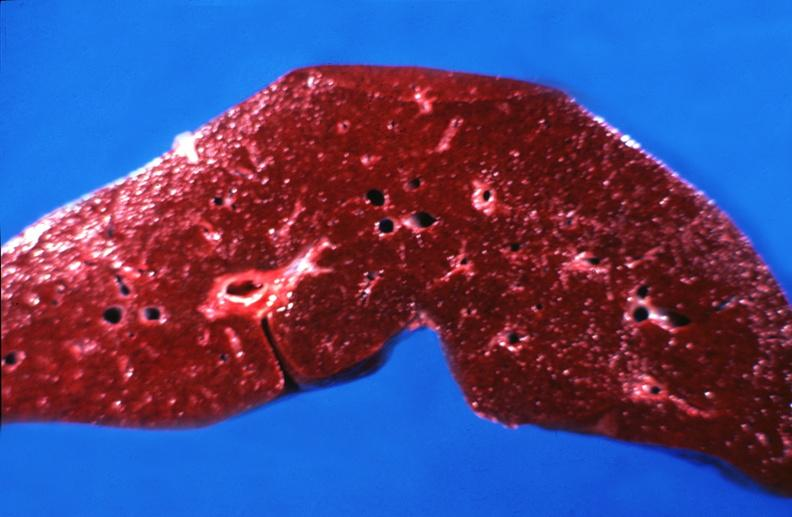s anomalous origin present?
Answer the question using a single word or phrase. No 